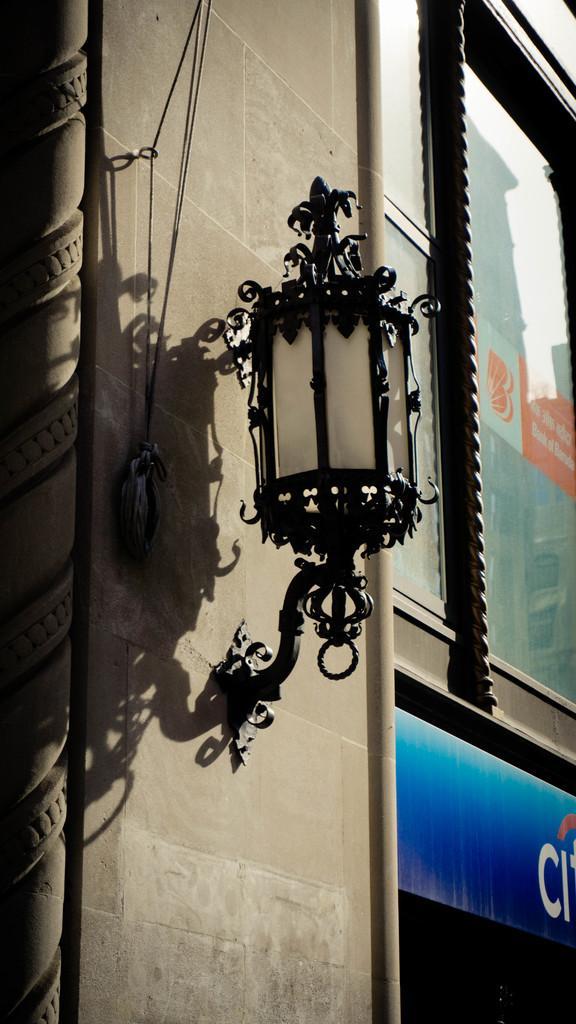Can you describe this image briefly? In the image we can see a wall, on the wall there is a light. 